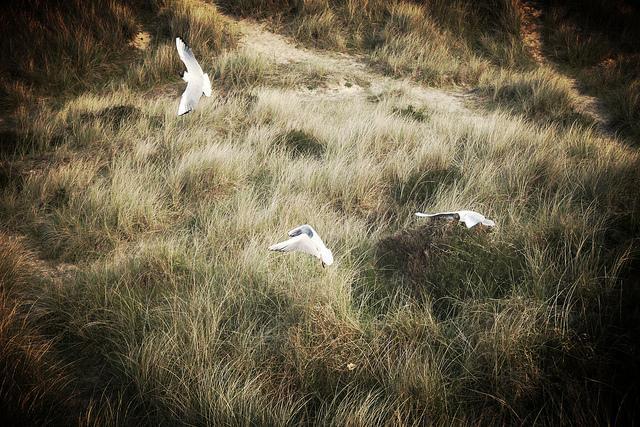How many birds are there?
Give a very brief answer. 3. How many animals are depicted?
Give a very brief answer. 3. How many birds?
Give a very brief answer. 3. How many elephant trunks can be seen?
Give a very brief answer. 0. 